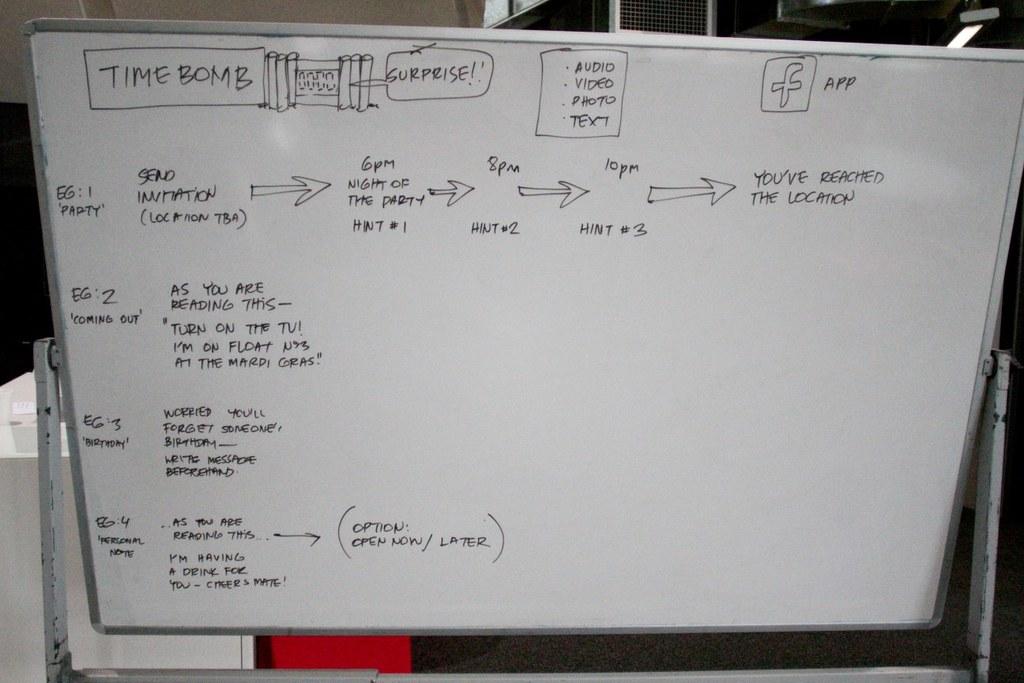What is the time bomb saying?
Make the answer very short. Surprise. 